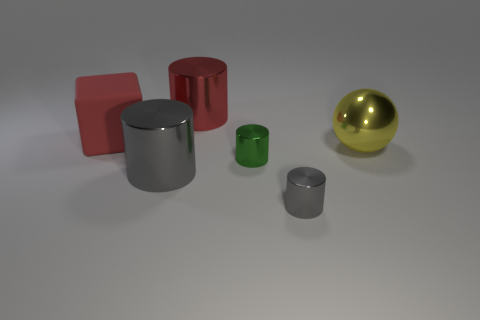What materials do the objects in the image appear to be made of? The objects in the image resemble materials like brightly colored plastic or painted metal for the colored cylinders and block, and polished metal for the shiny cylinder and sphere. 